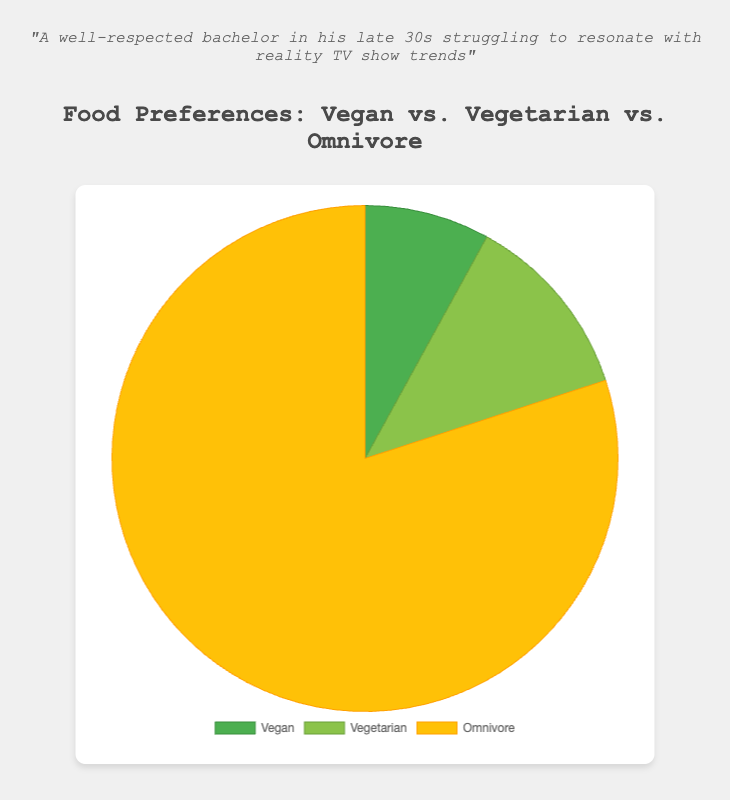What percentage of people are either Vegan or Vegetarian? Sum the percentages of Vegan and Vegetarian: 8.0% (Vegan) + 12.0% (Vegetarian) = 20.0%.
Answer: 20.0% Which category has the highest representation in the pie chart? Compare the percentages of all categories: Vegan (8.0%), Vegetarian (12.0%), and Omnivore (80.0%). Omnivore has the highest percentage.
Answer: Omnivore Are there more Vegans or Vegetarians? Compare the percentages of Vegan (8.0%) and Vegetarian (12.0%). 12.0% is greater than 8.0%.
Answer: Vegetarians How much greater is the percentage of Omnivores compared to Vegetarians? Subtract the percentage of Vegetarians from Omnivores: 80.0% (Omnivore) - 12.0% (Vegetarian) = 68.0%.
Answer: 68.0% What color represents the Vegan category in the pie chart? Identify the color associated with the Vegan segment in the pie chart, which is green.
Answer: Green How much less is the percentage of Vegans compared to Omnivores? Subtract the percentage of Vegans from Omnivores: 80.0% (Omnivore) - 8.0% (Vegan) = 72.0%.
Answer: 72.0% What is the combined percentage of Vegetarians and Omnivores? Sum the percentages of Vegetarians and Omnivores: 12.0% (Vegetarian) + 80.0% (Omnivore) = 92.0%.
Answer: 92.0% Which category is represented by the smallest segment in the pie chart? Compare the sizes of the pie chart segments for Vegan, Vegetarian, and Omnivore. The smallest segment corresponds to the Vegan category (8.0%).
Answer: Vegan 